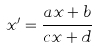<formula> <loc_0><loc_0><loc_500><loc_500>x ^ { \prime } = \frac { a x + b } { c x + d }</formula> 